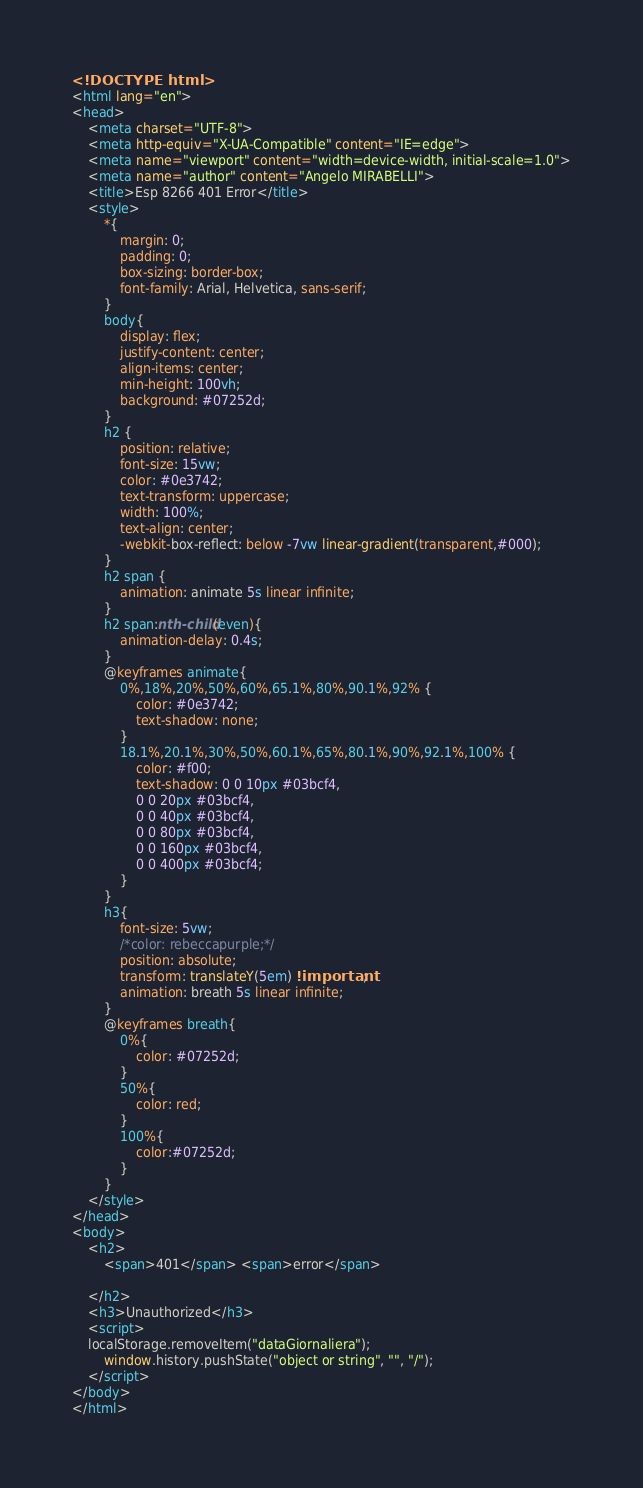<code> <loc_0><loc_0><loc_500><loc_500><_HTML_><!DOCTYPE html>
<html lang="en">
<head>
    <meta charset="UTF-8">
    <meta http-equiv="X-UA-Compatible" content="IE=edge">
    <meta name="viewport" content="width=device-width, initial-scale=1.0">
    <meta name="author" content="Angelo MIRABELLI">
    <title>Esp 8266 401 Error</title>
    <style>
        *{
            margin: 0;
            padding: 0;
            box-sizing: border-box;
            font-family: Arial, Helvetica, sans-serif;
        }
        body{
            display: flex;
            justify-content: center;
            align-items: center;
            min-height: 100vh;
            background: #07252d;
        }
        h2 {
            position: relative;
            font-size: 15vw;
            color: #0e3742;
            text-transform: uppercase;
            width: 100%;
            text-align: center;
            -webkit-box-reflect: below -7vw linear-gradient(transparent,#000);
        }
        h2 span {
            animation: animate 5s linear infinite;
        }
        h2 span:nth-child(even){
            animation-delay: 0.4s;
        }
        @keyframes animate{
            0%,18%,20%,50%,60%,65.1%,80%,90.1%,92% {
                color: #0e3742;
                text-shadow: none;
            }
            18.1%,20.1%,30%,50%,60.1%,65%,80.1%,90%,92.1%,100% {
                color: #f00;
                text-shadow: 0 0 10px #03bcf4,
                0 0 20px #03bcf4,
                0 0 40px #03bcf4,
                0 0 80px #03bcf4,
                0 0 160px #03bcf4,
                0 0 400px #03bcf4;
            }
        }
        h3{
            font-size: 5vw;
            /*color: rebeccapurple;*/
            position: absolute;
            transform: translateY(5em) !important;
            animation: breath 5s linear infinite;
        }
        @keyframes breath{
            0%{
                color: #07252d;
            }
            50%{
                color: red;
            }
            100%{
                color:#07252d;
            }
        }
    </style>
</head>
<body>
    <h2>
        <span>401</span> <span>error</span>
        
    </h2>
    <h3>Unauthorized</h3>
    <script>
	localStorage.removeItem("dataGiornaliera");
        window.history.pushState("object or string", "", "/");
    </script>	
</body>
</html></code> 